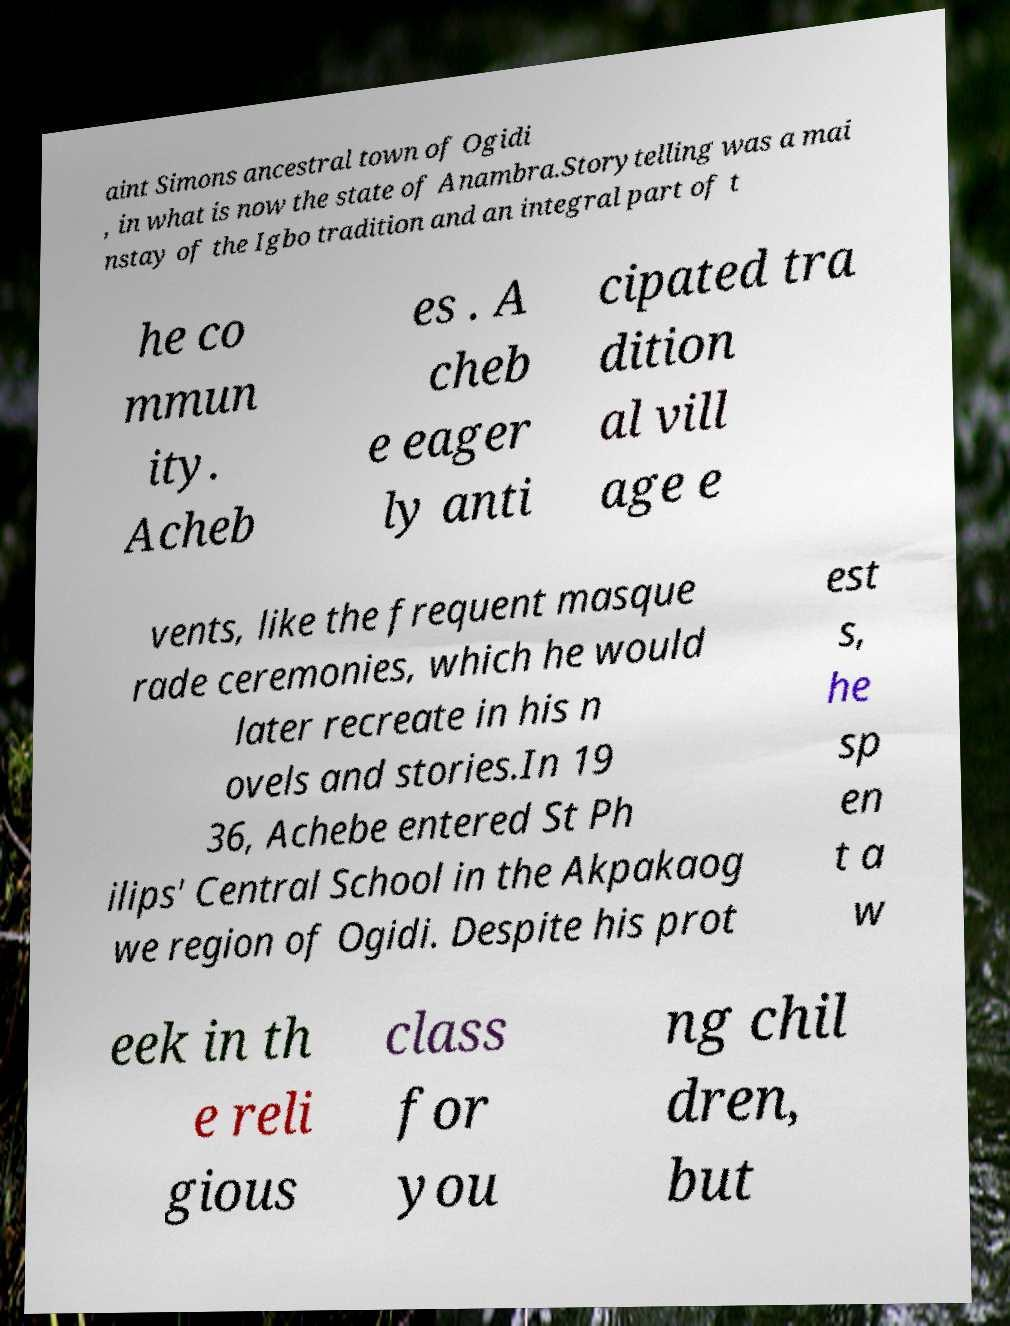Please identify and transcribe the text found in this image. aint Simons ancestral town of Ogidi , in what is now the state of Anambra.Storytelling was a mai nstay of the Igbo tradition and an integral part of t he co mmun ity. Acheb es . A cheb e eager ly anti cipated tra dition al vill age e vents, like the frequent masque rade ceremonies, which he would later recreate in his n ovels and stories.In 19 36, Achebe entered St Ph ilips' Central School in the Akpakaog we region of Ogidi. Despite his prot est s, he sp en t a w eek in th e reli gious class for you ng chil dren, but 